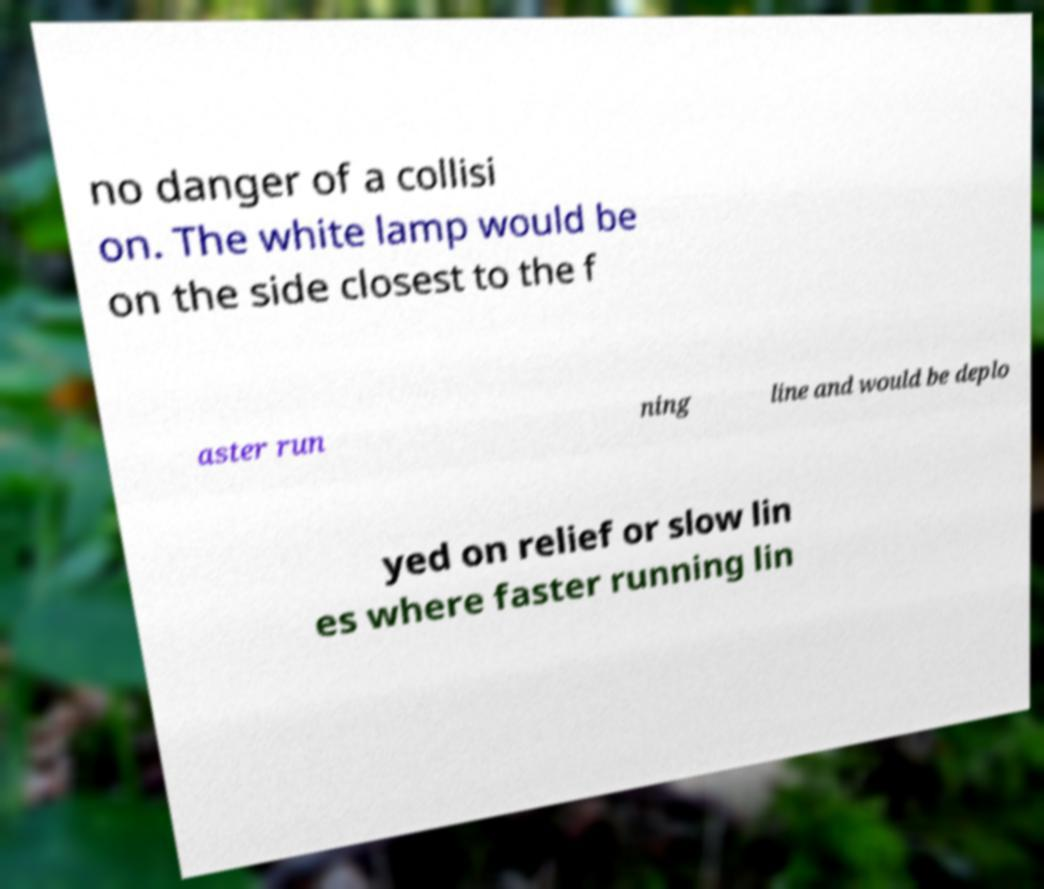Could you extract and type out the text from this image? no danger of a collisi on. The white lamp would be on the side closest to the f aster run ning line and would be deplo yed on relief or slow lin es where faster running lin 